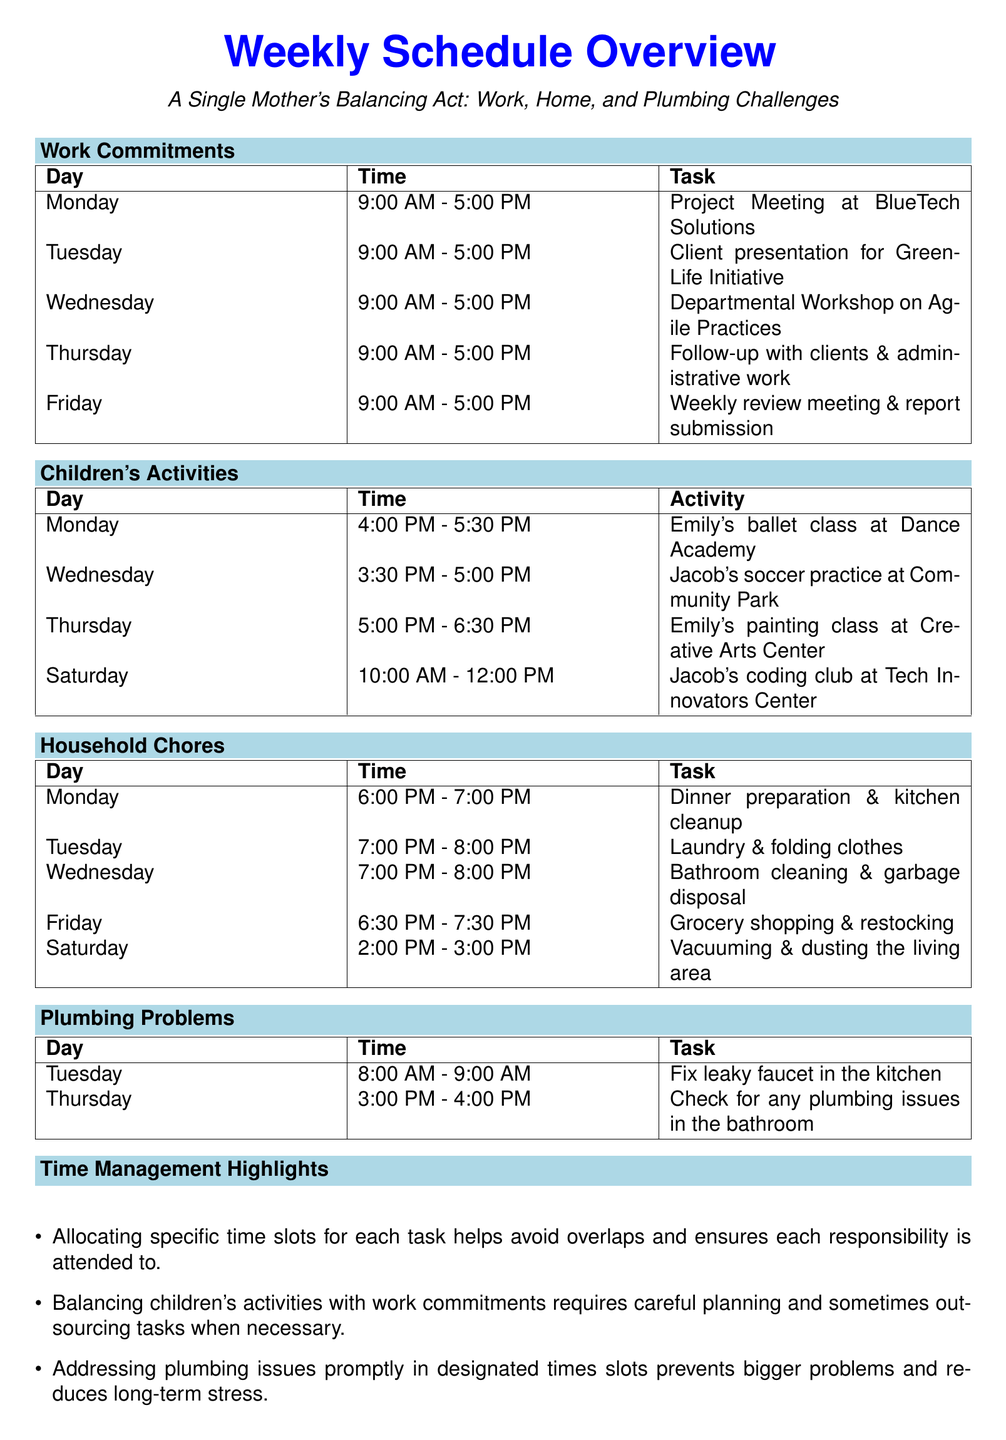What is the main work commitment on Monday? The work commitment for Monday is a project meeting at BlueTech Solutions scheduled from 9:00 AM to 5:00 PM.
Answer: Project Meeting at BlueTech Solutions At what time is Emily's ballet class? Emily's ballet class is held on Monday from 4:00 PM to 5:30 PM.
Answer: 4:00 PM - 5:30 PM Which household chore is scheduled for Tuesday? The household chore scheduled for Tuesday is laundry and folding clothes from 7:00 PM to 8:00 PM.
Answer: Laundry & folding clothes What time is the plumbing issue check on Thursday? The plumbing issue check on Thursday is scheduled from 3:00 PM to 4:00 PM.
Answer: 3:00 PM - 4:00 PM How many children's activities occur during the week? There are four children's activities listed in the document.
Answer: Four Which day has both a work commitment and a plumbing task? Tuesday has both a work commitment and a plumbing task scheduled for the same day.
Answer: Tuesday What strategy is suggested for managing plumbing issues? The document suggests addressing plumbing issues promptly in designated time slots.
Answer: Designated time slots What time is grocery shopping scheduled? Grocery shopping is scheduled for Friday from 6:30 PM to 7:30 PM.
Answer: 6:30 PM - 7:30 PM 